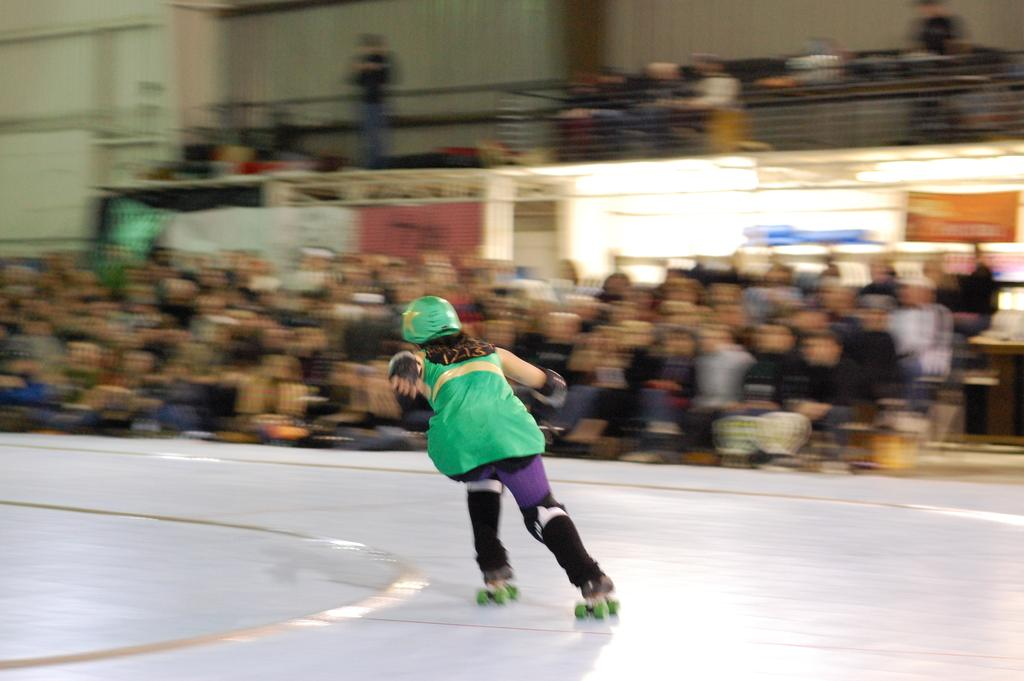How many people are in the image? There are a few people in the image. What are the people in the image doing? One person is skating. Can you describe the background of the image? The background of the image is blurred. What type of spark can be seen coming from the skater's shoes in the image? There is no spark coming from the skater's shoes in the image. Is there a locket hanging from the skater's neck in the image? There is no locket visible in the image. 